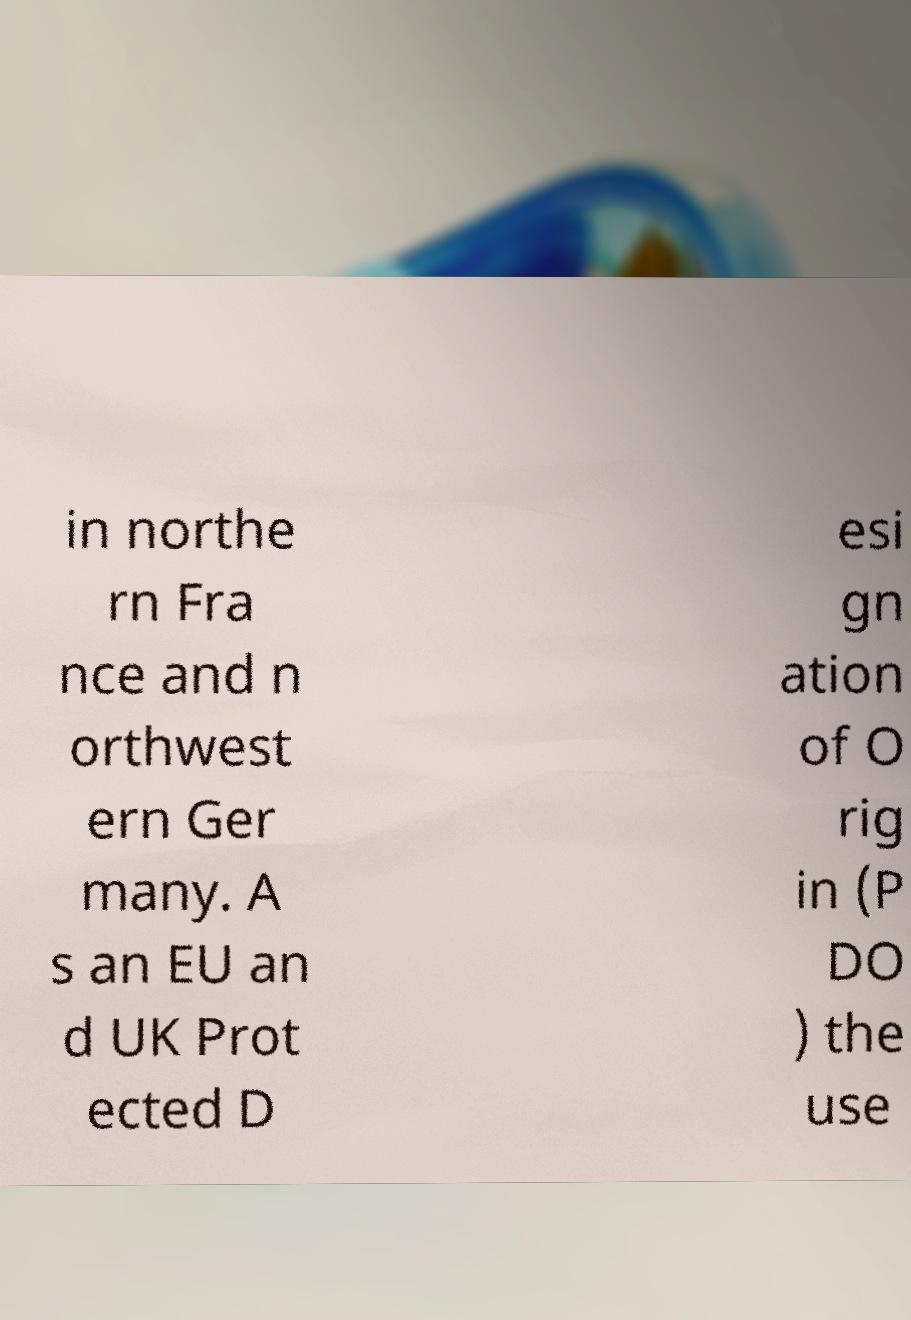What messages or text are displayed in this image? I need them in a readable, typed format. in northe rn Fra nce and n orthwest ern Ger many. A s an EU an d UK Prot ected D esi gn ation of O rig in (P DO ) the use 